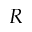<formula> <loc_0><loc_0><loc_500><loc_500>R</formula> 